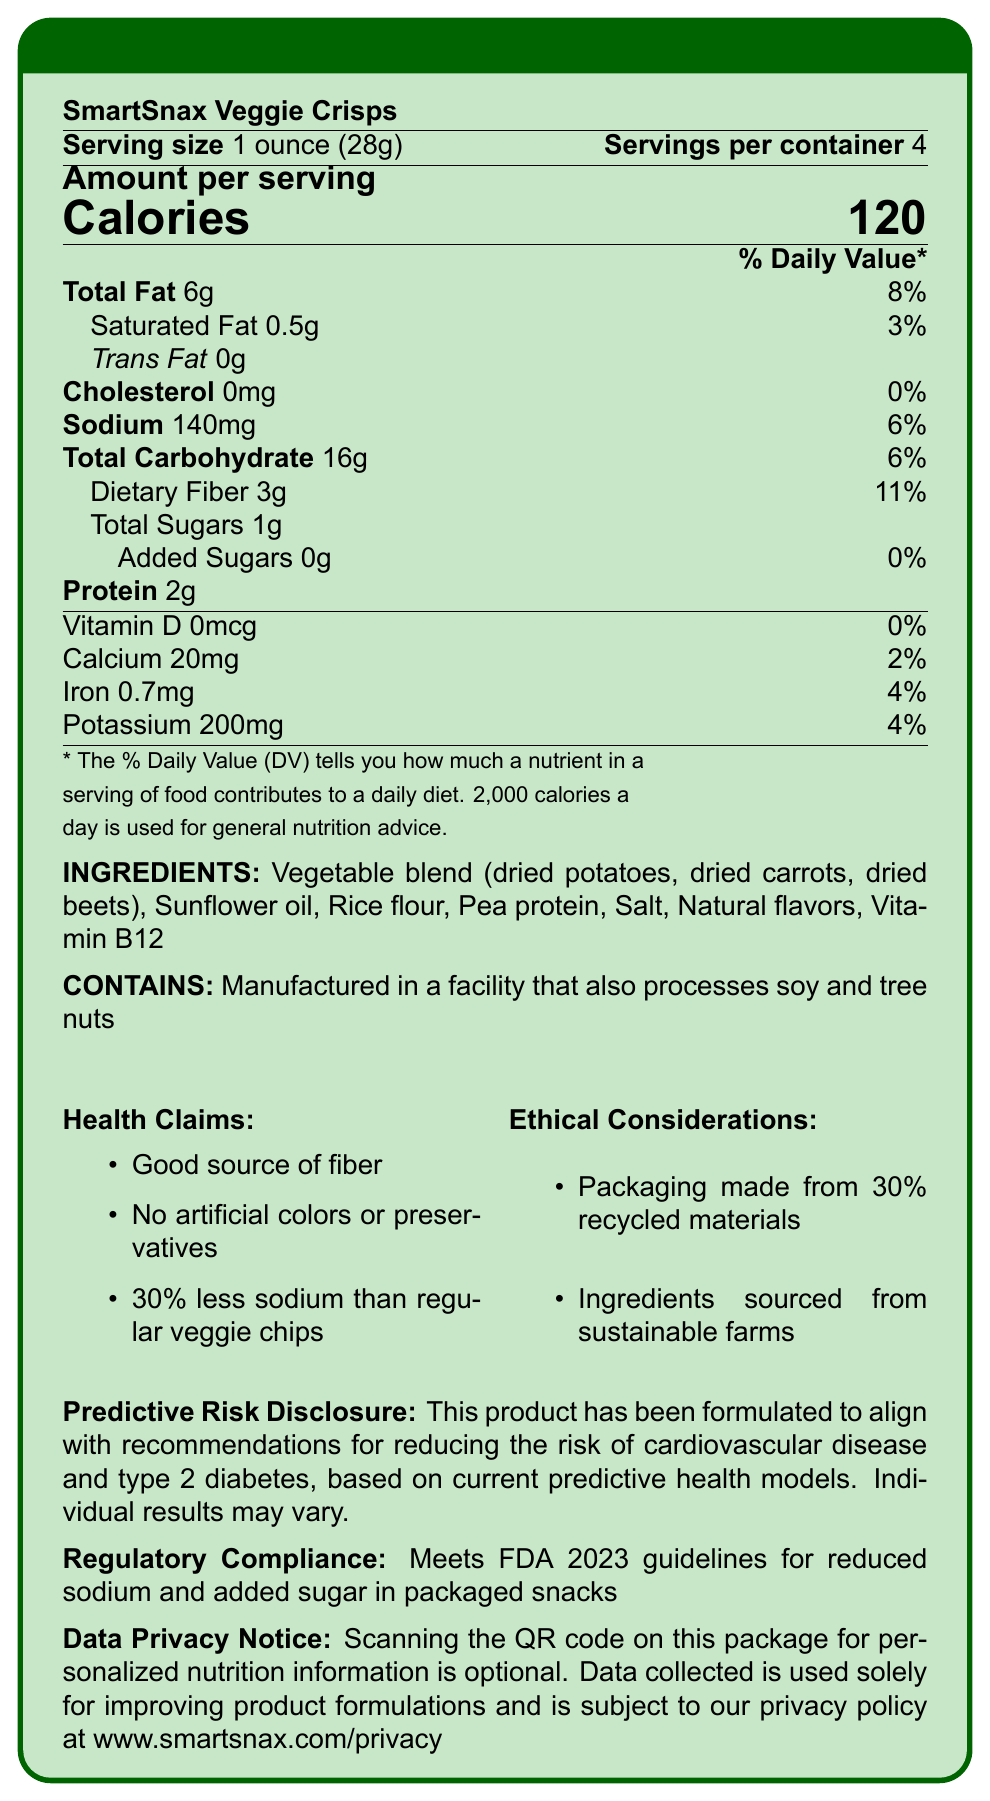what is the serving size for SmartSnax Veggie Crisps? The document states the serving size directly under the product name.
Answer: 1 ounce (28g) how many calories are in one serving of SmartSnax Veggie Crisps? The calorie information is displayed prominently in the "Amount per serving" section.
Answer: 120 how much sodium is in a single serving? The sodium content is listed under the "Amount per serving" section with a daily value of 6%.
Answer: 140mg which type of fat is entirely absent from SmartSnax Veggie Crisps? The document states "Trans Fat 0g" below the total fat content.
Answer: Trans Fat what percentage of the daily value for dietary fiber does one serving provide? The daily value percentage for dietary fiber is listed as 11% next to its amount.
Answer: 11% what are the main ingredients in SmartSnax Veggie Crisps? The ingredients are listed under the bold heading "INGREDIENTS".
Answer: Vegetable blend (dried potatoes, dried carrots, dried beets), Sunflower oil, Rice flour, Pea protein, Salt, Natural flavors, Vitamin B12 what allergen warning is provided for this product? This information is listed under the bold heading "CONTAINS".
Answer: Manufactured in a facility that also processes soy and tree nuts how many servings are there in one container? A. 2 B. 3 C. 4 D. 6 The document specifies "Servings per container: 4" under the serving size.
Answer: C. 4 which health claim is NOT made about SmartSnax Veggie Crisps? A. No trans fat B. Good source of fiber C. No artificial colors or preservatives D. 30% less sodium than regular veggie chips The health claims listed include "Good source of fiber", "No artificial colors or preservatives", and "30% less sodium than regular veggie chips"; "No trans fat" is not one of them.
Answer: A. No trans fat is this product considered a good source of fiber? One of the health claims listed is "Good source of fiber."
Answer: Yes describe the main idea of the document. The document provides comprehensive information about the product's nutritional value, ingredient list, health and ethical claims, and compliance with regulatory standards.
Answer: The document details the nutrition facts, ingredients, health claims, ethical considerations, and regulatory compliance of SmartSnax Veggie Crisps, emphasizing their alignment with new government health guidelines. how much potassium is in one serving of SmartSnax Veggie Crisps? The potassium content is detailed under the nutrient section with a daily value of 4%.
Answer: 200mg which vitamin is added to SmartSnax Veggie Crisps? The ingredient list includes "Vitamin B12".
Answer: Vitamin B12 how much total carbohydrate does one serving contain? The total carbohydrate amount is listed under the nutrient section with a daily value of 6%.
Answer: 16g is there any added sugar in SmartSnax Veggie Crisps? The document specifies "Added Sugars 0g" under the carbohydrate section.
Answer: No what percentage of the daily value for calcium is provided in one serving? The daily value for calcium is listed as 2%.
Answer: 2% has the product been formulated to reduce the risk of cardiovascular disease and type 2 diabetes? The predictive risk disclosure clearly states the product's formulation aims to reduce the risk of these conditions.
Answer: Yes what is the daily value percentage for iron in this product? The iron content provides 4% of the daily value.
Answer: 4% does this product contain any cholesterol? The document mentions "Cholesterol 0mg" with a daily value of 0%.
Answer: No how many grams of protein are in one serving? The protein content of one serving is listed as 2g.
Answer: 2g what is the environmental impact mentioned for SmartSnax Veggie Crisps? This information is listed under "Ethical Considerations".
Answer: Packaging made from 30% recycled materials can you determine the specific farms from which the ingredients are sourced? The document mentions "sourced from sustainable farms" but doesn’t provide specific details about the farms.
Answer: Not enough information what is required to access personalized nutrition information for this product? The data privacy notice states that scanning the QR code on the package provides access to personalized nutrition information.
Answer: Scanning the QR code on the package 